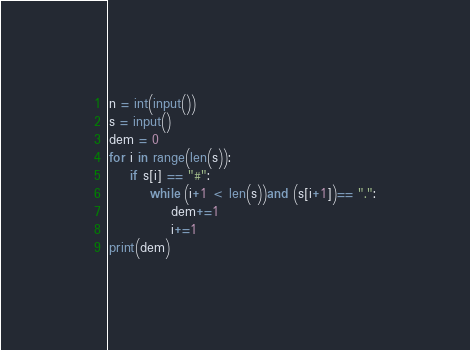<code> <loc_0><loc_0><loc_500><loc_500><_Python_>n = int(input())
s = input()
dem = 0
for i in range(len(s)):
    if s[i] == "#":
        while (i+1 < len(s))and (s[i+1])== ".":
            dem+=1
            i+=1
print(dem)</code> 